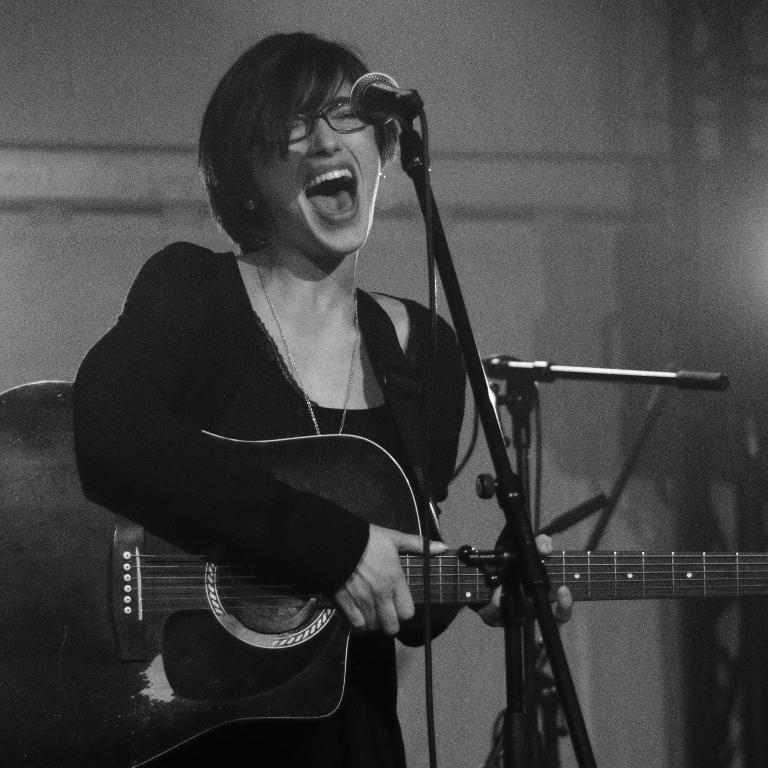Who is the main subject in the image? There is a woman in the image. What is the woman doing in the image? The woman is standing, holding a guitar, and singing near a microphone. What can be seen in the background of the image? There is a wall in the background of the image. How many mice are running around the woman's feet in the image? There are no mice present in the image. What type of record is the woman breaking in the image? There is no record-breaking activity depicted in the image; the woman is simply singing with a guitar and microphone. 